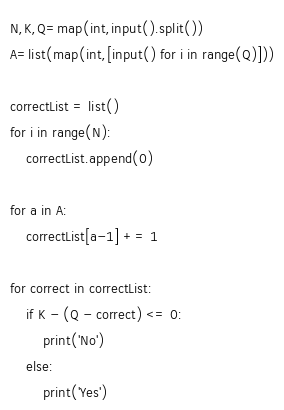<code> <loc_0><loc_0><loc_500><loc_500><_Python_>N,K,Q=map(int,input().split())
A=list(map(int,[input() for i in range(Q)]))

correctList = list()
for i in range(N):
    correctList.append(0)

for a in A:
    correctList[a-1] += 1

for correct in correctList:
    if K - (Q - correct) <= 0:
        print('No')
    else:
        print('Yes')
</code> 